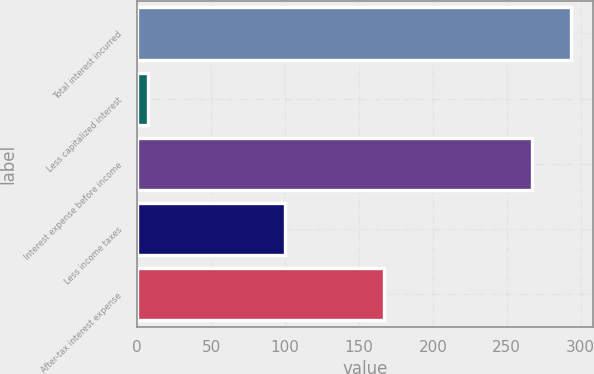Convert chart. <chart><loc_0><loc_0><loc_500><loc_500><bar_chart><fcel>Total interest incurred<fcel>Less capitalized interest<fcel>Interest expense before income<fcel>Less income taxes<fcel>After-tax interest expense<nl><fcel>293.7<fcel>7<fcel>267<fcel>100<fcel>167<nl></chart> 